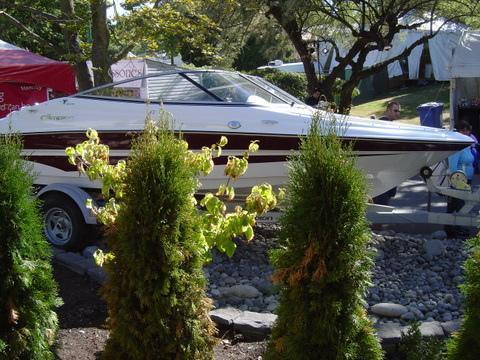How many boats are there?
Give a very brief answer. 1. How many toothbrushes are in this picture?
Give a very brief answer. 0. 